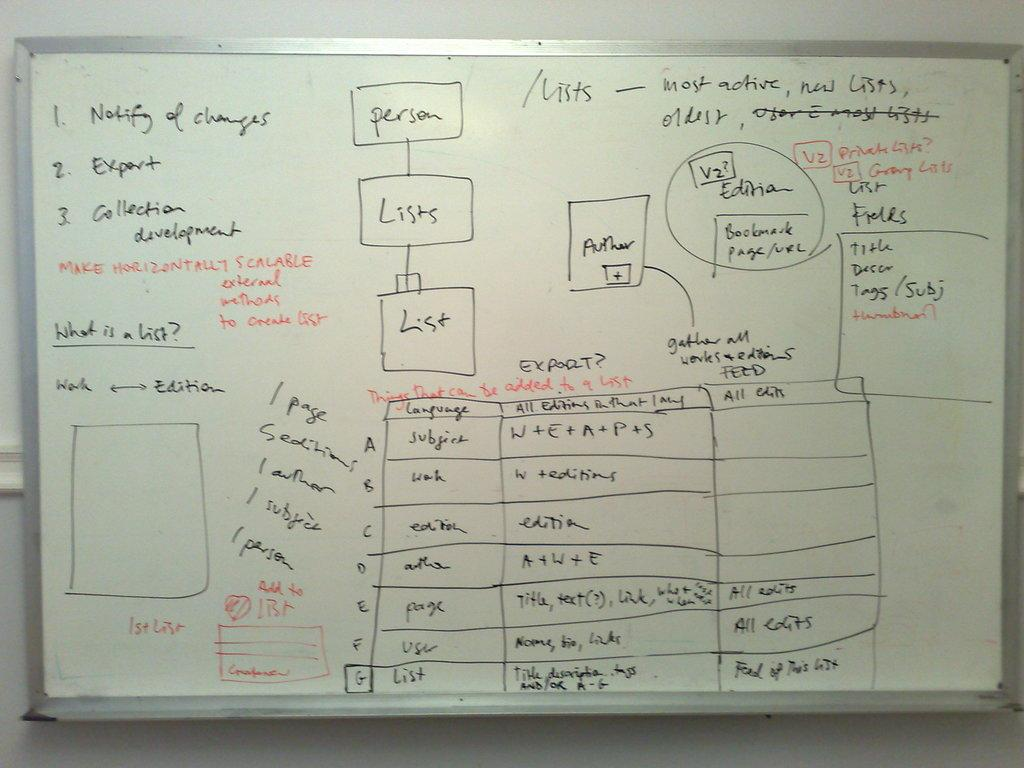<image>
Create a compact narrative representing the image presented. A whiteboard says that number 2 is export. 